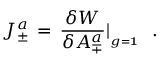<formula> <loc_0><loc_0><loc_500><loc_500>J _ { \pm } ^ { a } \, = \, { \frac { \delta W } { \delta A _ { \mp } ^ { a } } } | _ { _ { g = { 1 } } } \, .</formula> 